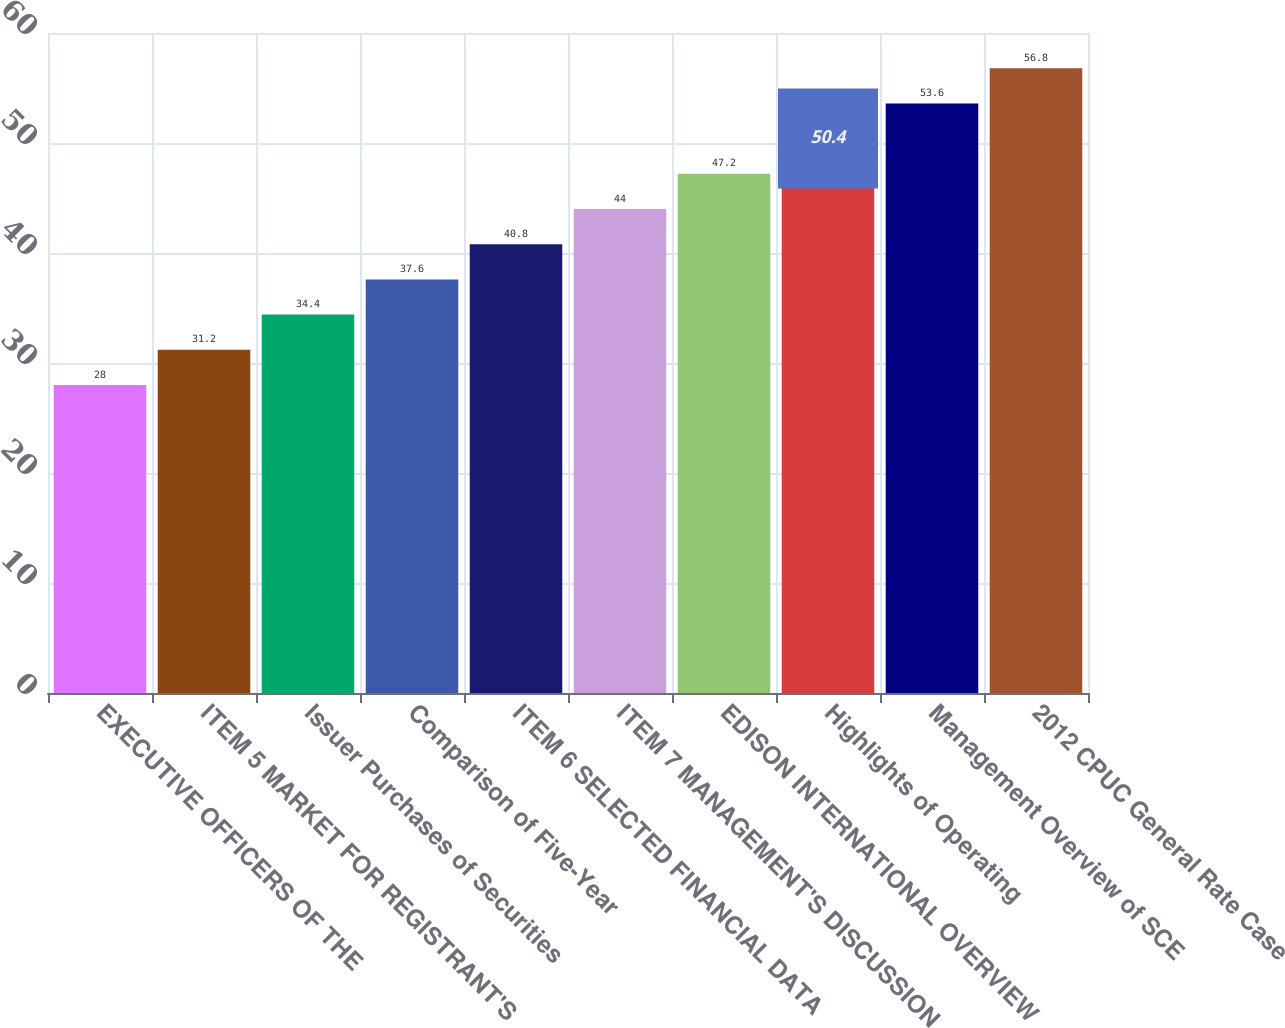Convert chart to OTSL. <chart><loc_0><loc_0><loc_500><loc_500><bar_chart><fcel>EXECUTIVE OFFICERS OF THE<fcel>ITEM 5 MARKET FOR REGISTRANT'S<fcel>Issuer Purchases of Securities<fcel>Comparison of Five-Year<fcel>ITEM 6 SELECTED FINANCIAL DATA<fcel>ITEM 7 MANAGEMENT'S DISCUSSION<fcel>EDISON INTERNATIONAL OVERVIEW<fcel>Highlights of Operating<fcel>Management Overview of SCE<fcel>2012 CPUC General Rate Case<nl><fcel>28<fcel>31.2<fcel>34.4<fcel>37.6<fcel>40.8<fcel>44<fcel>47.2<fcel>50.4<fcel>53.6<fcel>56.8<nl></chart> 